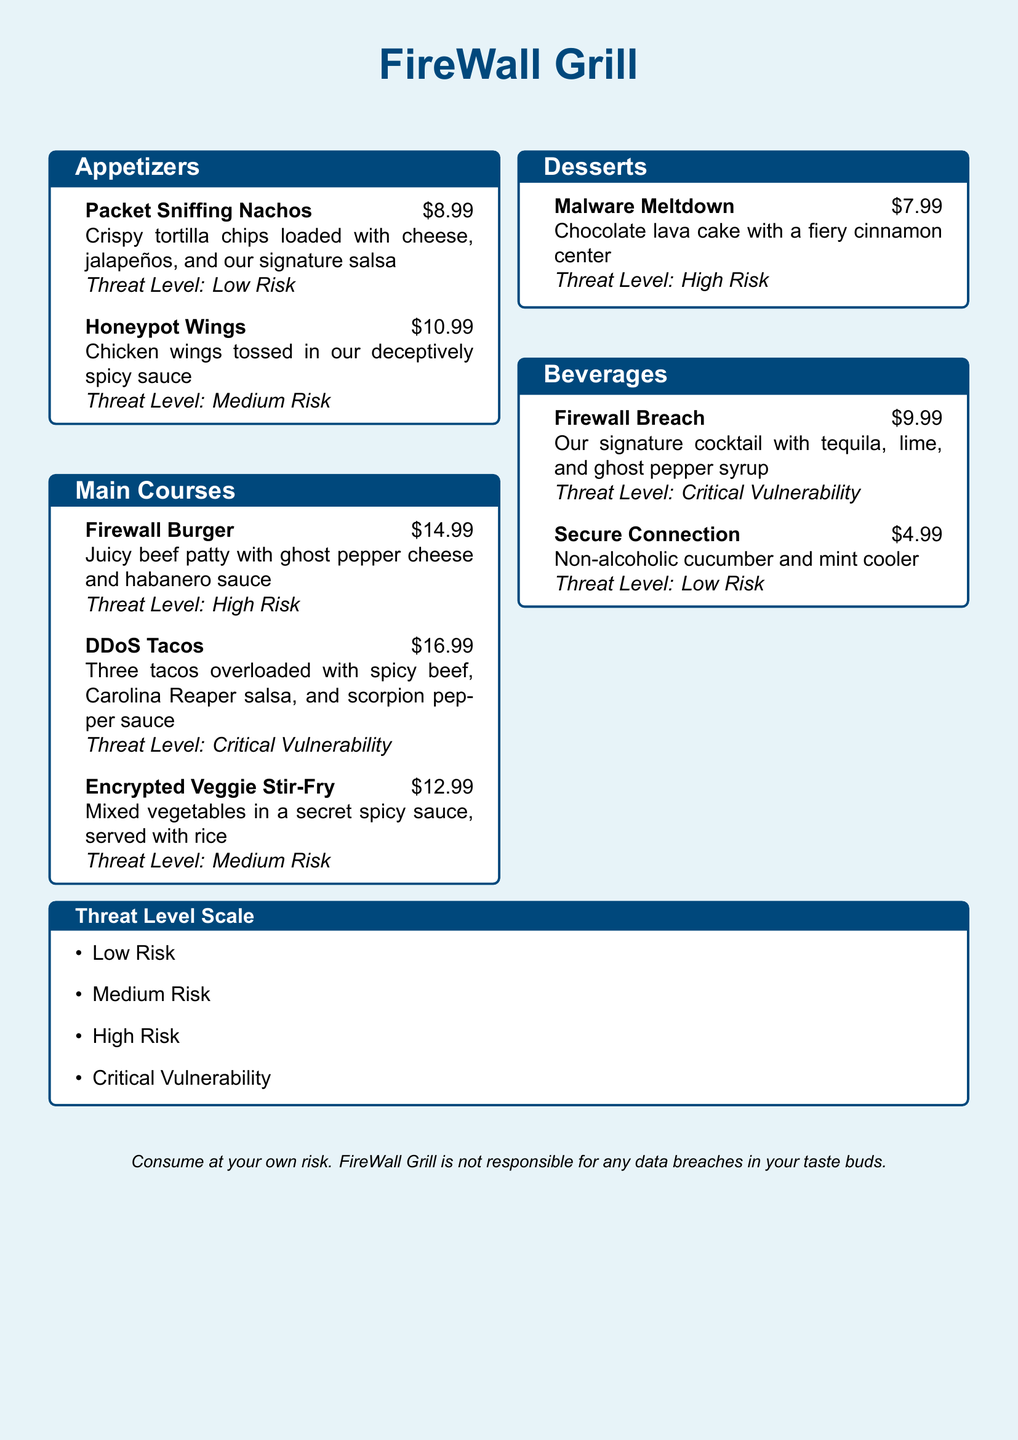What is the price of the Packet Sniffing Nachos? The price of the Packet Sniffing Nachos is found alongside its description in the appetizers section.
Answer: $8.99 What is the Threat Level of the DDoS Tacos? The Threat Level for the DDoS Tacos is indicated in the description of the main courses.
Answer: Critical Vulnerability Which dessert has a Threat Level of High Risk? The document outlines the Threat Levels for each dessert and identifies which ones fall into specific categories.
Answer: Malware Meltdown What ingredients are in the Firewall Breach cocktail? The ingredients for the Firewall Breach cocktail are listed in the beverages section along with its Threat Level.
Answer: Tequila, lime, and ghost pepper syrup How many appetizers are listed on the menu? The total number of appetizers can be counted in the appetizers section of the document.
Answer: 2 What is the Threat Level of the Secure Connection? The Threat Level is stated in the beverages section next to the description of the Secure Connection.
Answer: Low Risk What is the price of the Firewall Burger? The price of the Firewall Burger is mentioned in the main courses section next to its description.
Answer: $14.99 Which dish is described as having a fiery cinnamon center? The description for each dessert includes unique characteristics, allowing identification.
Answer: Malware Meltdown 